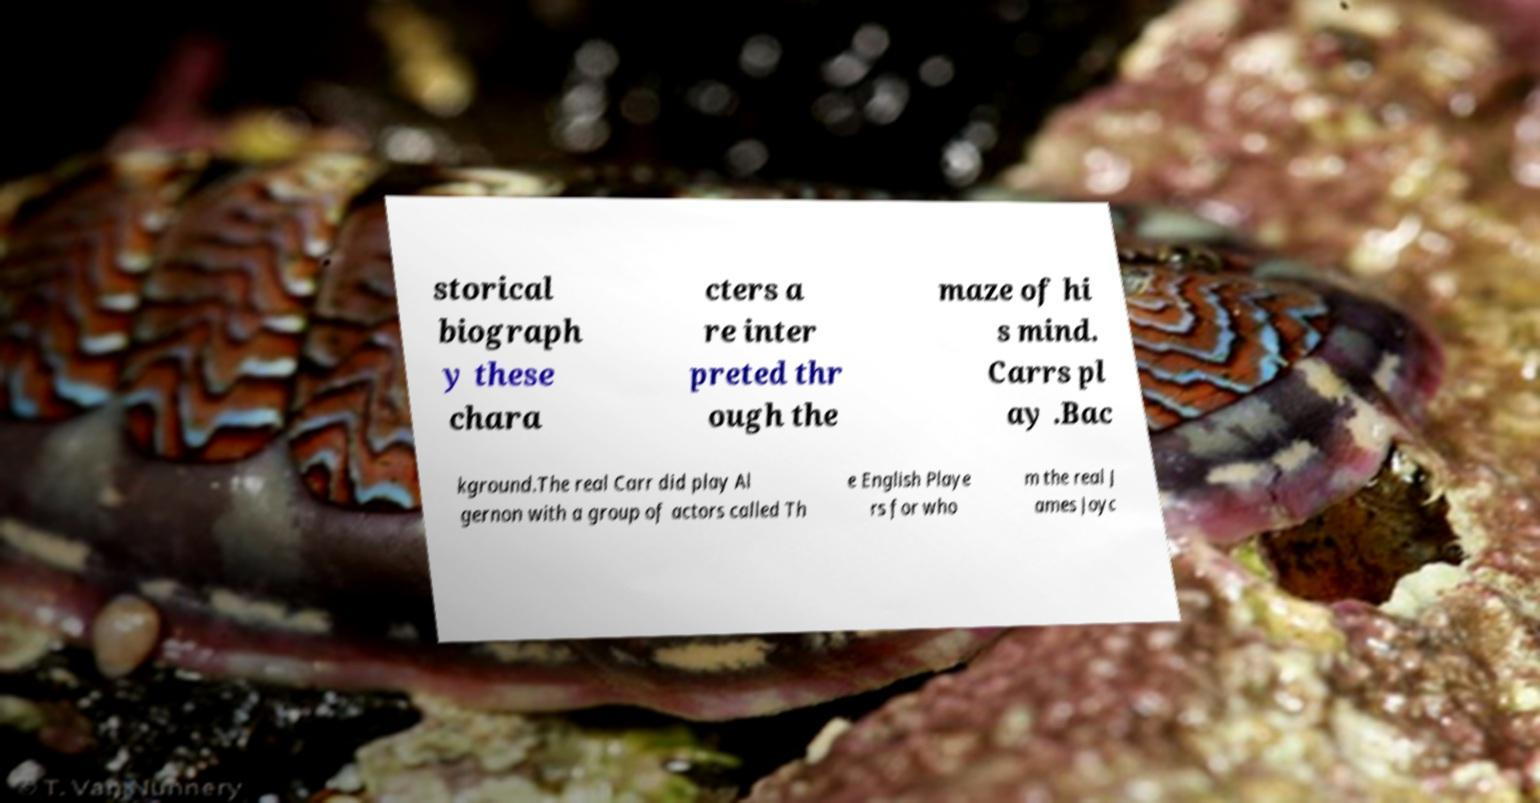Can you read and provide the text displayed in the image?This photo seems to have some interesting text. Can you extract and type it out for me? storical biograph y these chara cters a re inter preted thr ough the maze of hi s mind. Carrs pl ay .Bac kground.The real Carr did play Al gernon with a group of actors called Th e English Playe rs for who m the real J ames Joyc 